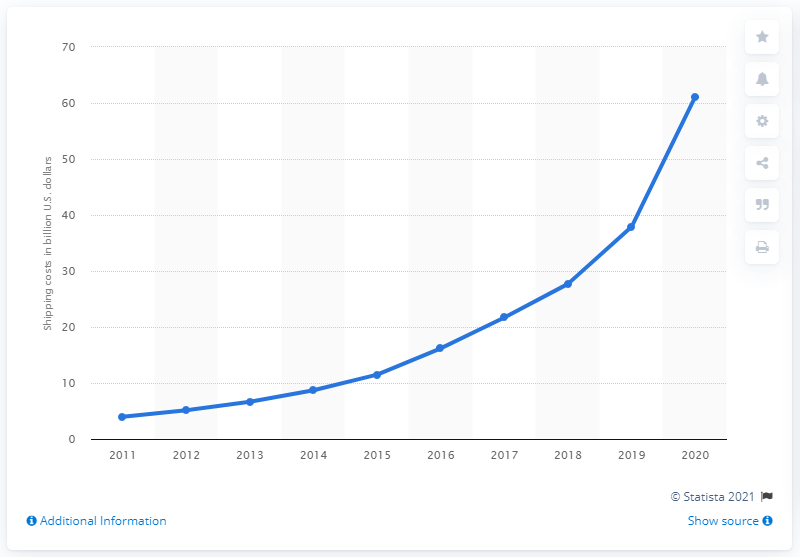Outline some significant characteristics in this image. Amazon's shipping costs in the previous year were 37.9%. Amazon's shipping costs in the most recent fiscal year were 61.1%. 